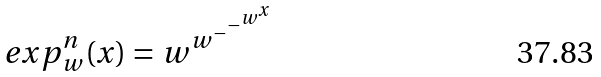<formula> <loc_0><loc_0><loc_500><loc_500>e x p _ { w } ^ { n } ( x ) = w ^ { w ^ { - ^ { - ^ { w ^ { x } } } } }</formula> 